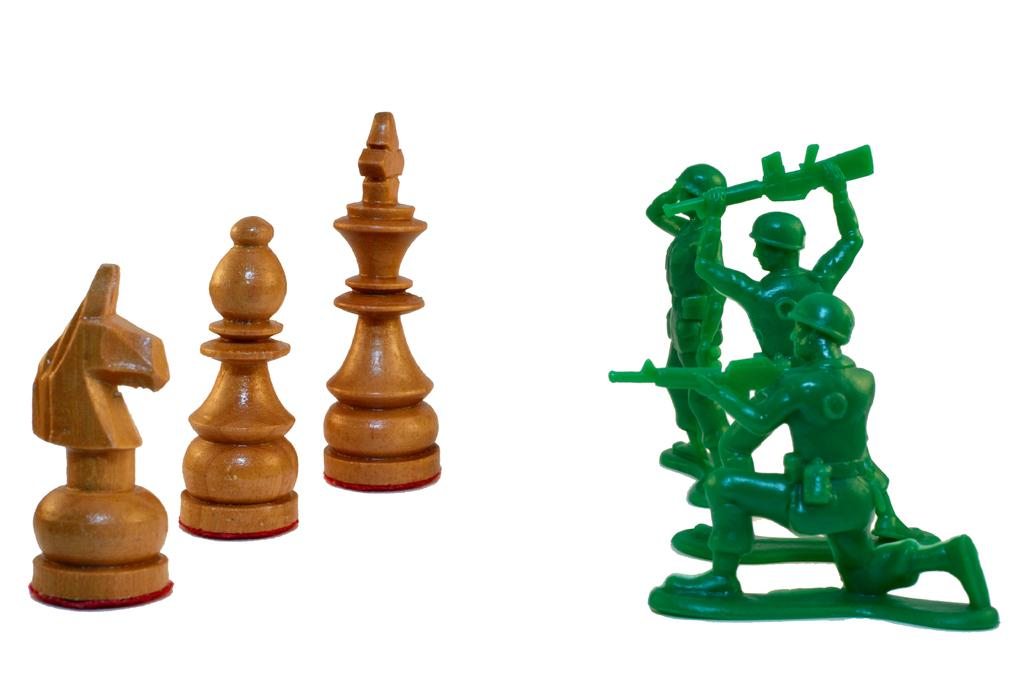What type of game pieces are present in the image? There are chess pawns in the image. What color are the chess pawns? The chess pawns are brown in color. What other figures are present in the image? There are green color person dolls in the image. What are the green color person dolls holding? The green color person dolls are holding guns. What type of canvas is visible in the image? There is no canvas present in the image. How many dogs are visible in the image? There are no dogs present in the image. 